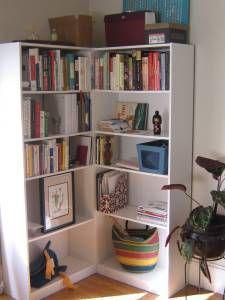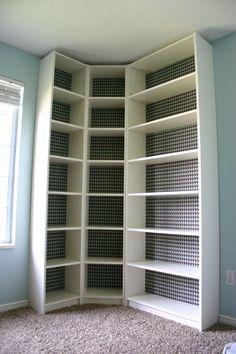The first image is the image on the left, the second image is the image on the right. For the images shown, is this caption "One image shows a completely empty white shelf while the other shows a shelf with contents, and all shelves are designed to fit in a corner." true? Answer yes or no. Yes. The first image is the image on the left, the second image is the image on the right. For the images displayed, is the sentence "A shelf unit consists of two tall, narrow shelves of equal size, placed at ninety degree angles to each other in the corner of a room." factually correct? Answer yes or no. Yes. 